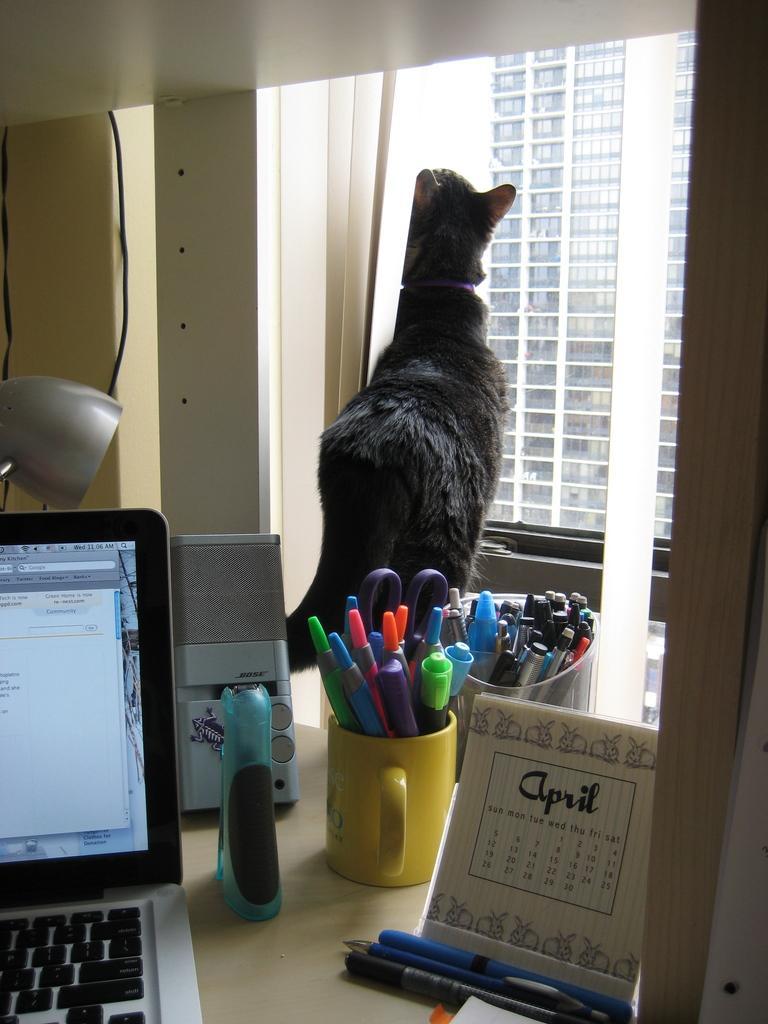In one or two sentences, can you explain what this image depicts? On the table to the left side there is a laptop, and to the right side there is a calendar and pens in front of it. And in the middle there is a torch light, a cup with many pens in it and a speaker. And to the left corner there is a lamp. And in the middle there is a cat peeing outside the window. Outside the window there is a building. 